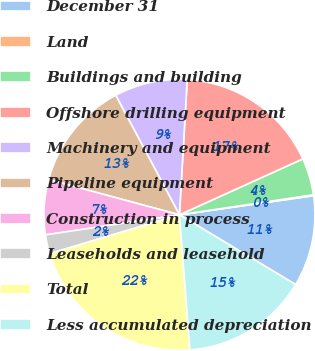Convert chart to OTSL. <chart><loc_0><loc_0><loc_500><loc_500><pie_chart><fcel>December 31<fcel>Land<fcel>Buildings and building<fcel>Offshore drilling equipment<fcel>Machinery and equipment<fcel>Pipeline equipment<fcel>Construction in process<fcel>Leaseholds and leasehold<fcel>Total<fcel>Less accumulated depreciation<nl><fcel>10.86%<fcel>0.11%<fcel>4.41%<fcel>17.31%<fcel>8.71%<fcel>13.01%<fcel>6.56%<fcel>2.26%<fcel>21.61%<fcel>15.16%<nl></chart> 